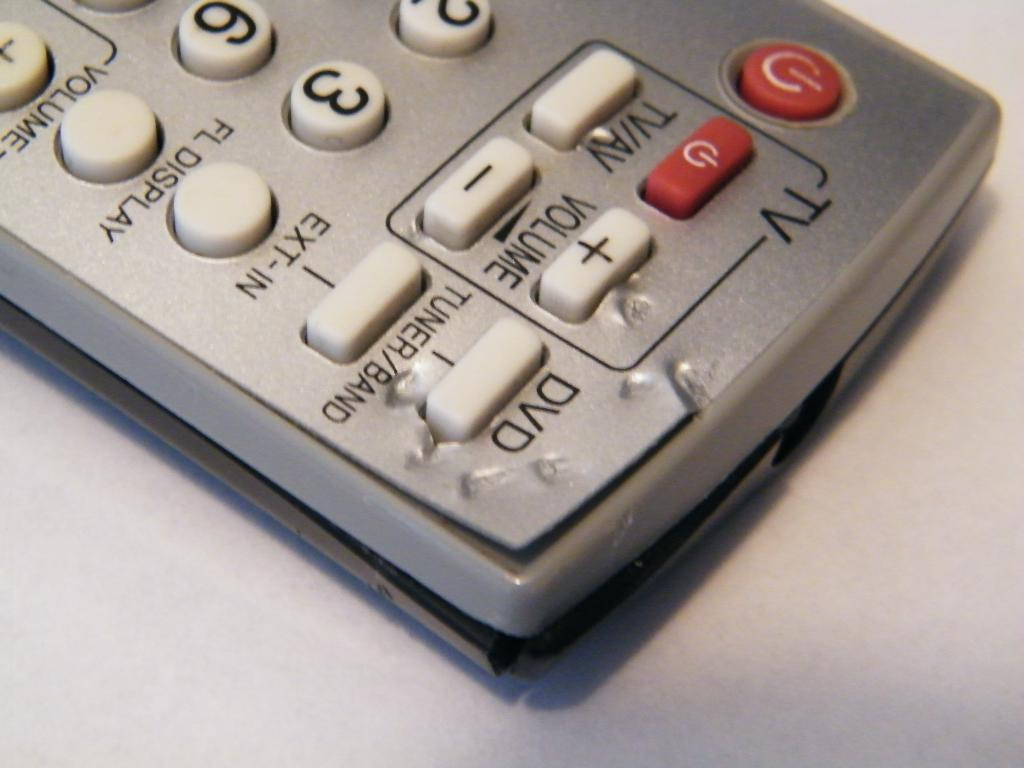<image>
Present a compact description of the photo's key features. A silver remote that has buttons for TV and DVD 